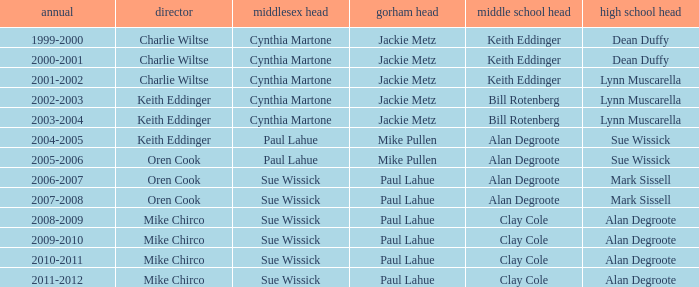How many high school principals were there in 2000-2001? Dean Duffy. 